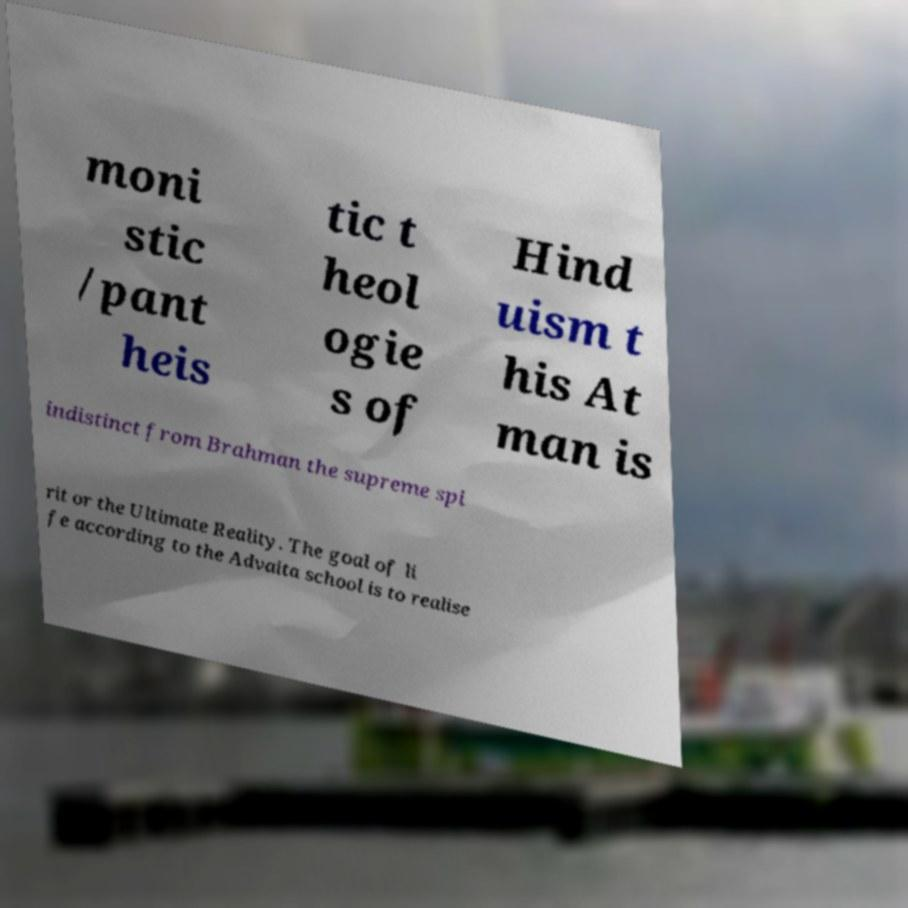Can you accurately transcribe the text from the provided image for me? moni stic /pant heis tic t heol ogie s of Hind uism t his At man is indistinct from Brahman the supreme spi rit or the Ultimate Reality. The goal of li fe according to the Advaita school is to realise 